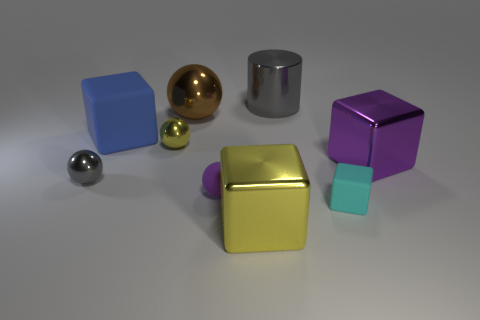How many blocks are either brown things or big purple things? In the image, there is one big purple block visible amongst the objects. 